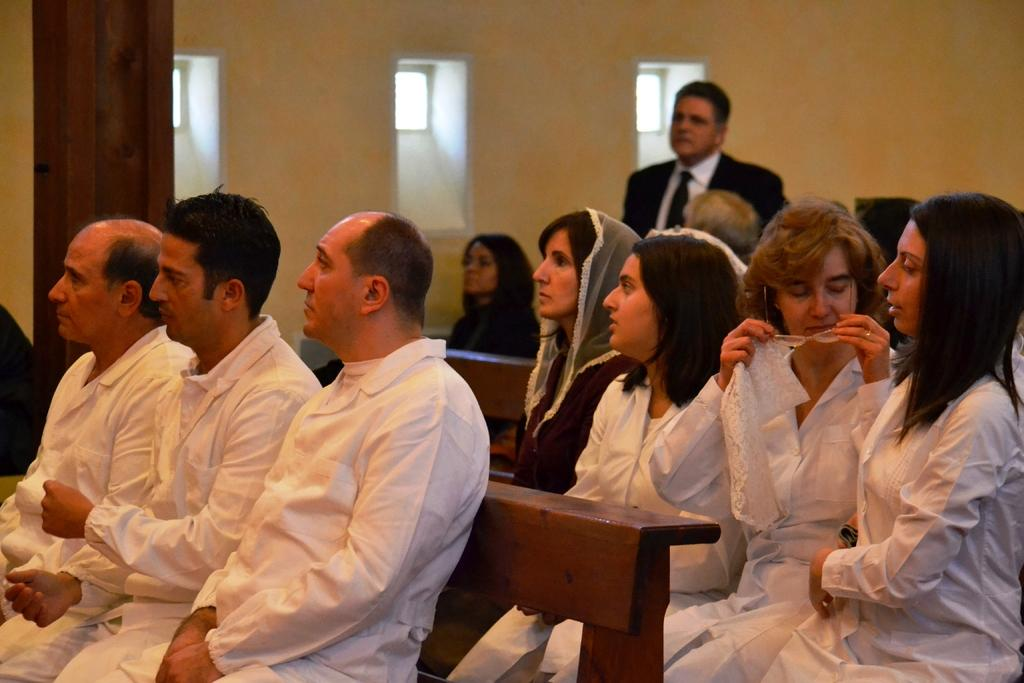What are the people in the image doing? The people in the image are sitting on benches. Can you describe the person in the background of the image? There is a person standing in the background of the image. What type of rice is being served at the feast in the image? There is no mention of rice or any feast in the image. 